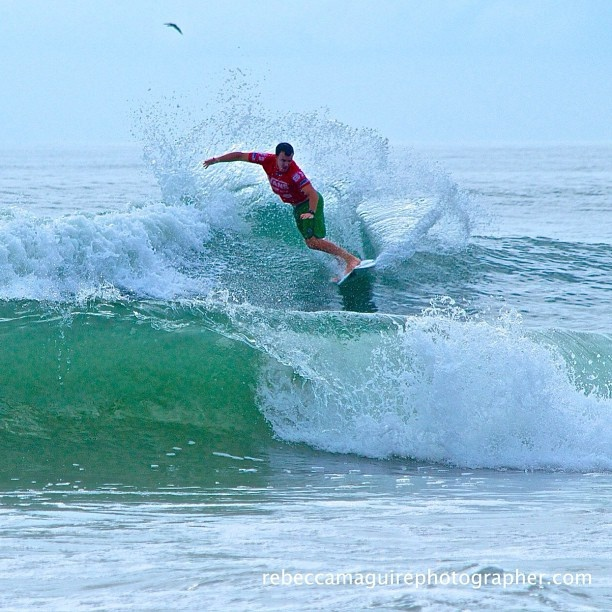Describe the objects in this image and their specific colors. I can see people in lightblue, black, maroon, brown, and purple tones, surfboard in lightblue, teal, and darkblue tones, and bird in lightblue, blue, and gray tones in this image. 